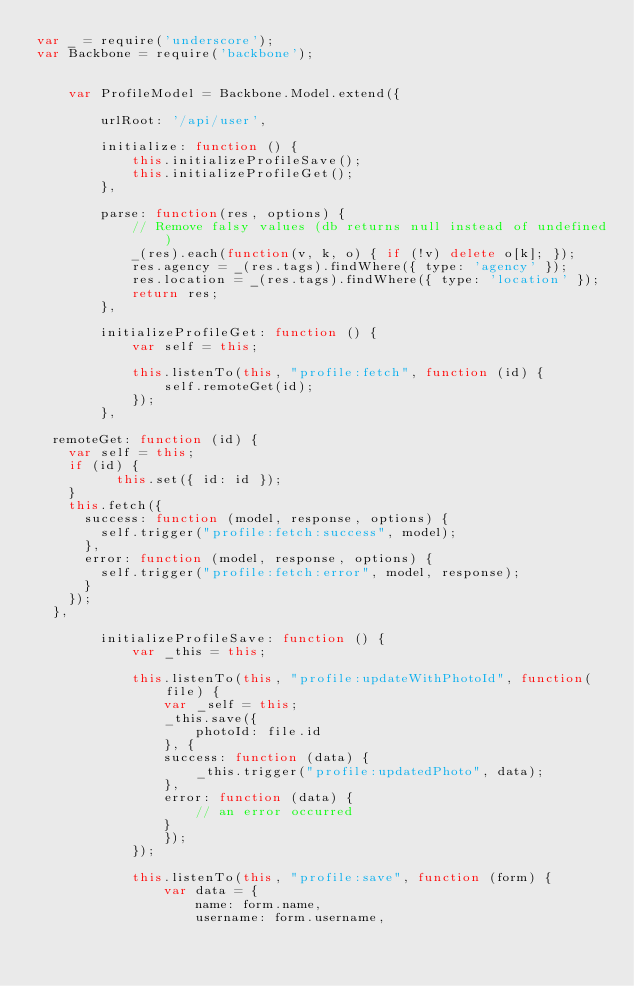<code> <loc_0><loc_0><loc_500><loc_500><_JavaScript_>var _ = require('underscore');
var Backbone = require('backbone');


	var ProfileModel = Backbone.Model.extend({

		urlRoot: '/api/user',

		initialize: function () {
			this.initializeProfileSave();
			this.initializeProfileGet();
		},

		parse: function(res, options) {
			// Remove falsy values (db returns null instead of undefined)
			_(res).each(function(v, k, o) { if (!v) delete o[k]; });
			res.agency = _(res.tags).findWhere({ type: 'agency' });
			res.location = _(res.tags).findWhere({ type: 'location' });
			return res;
		},

		initializeProfileGet: function () {
			var self = this;

			this.listenTo(this, "profile:fetch", function (id) {
				self.remoteGet(id);
			});
		},

  remoteGet: function (id) {
    var self = this;
    if (id) {
	      this.set({ id: id });
    }
    this.fetch({
      success: function (model, response, options) {
        self.trigger("profile:fetch:success", model);
      },
      error: function (model, response, options) {
        self.trigger("profile:fetch:error", model, response);
      }
    });
  },

		initializeProfileSave: function () {
			var _this = this;

			this.listenTo(this, "profile:updateWithPhotoId", function(file) {
				var _self = this;
				_this.save({
					photoId: file.id
				}, {
				success: function (data) {
					_this.trigger("profile:updatedPhoto", data);
				},
				error: function (data) {
					// an error occurred
				}
				});
			});

			this.listenTo(this, "profile:save", function (form) {
				var data = {
					name: form.name,
					username: form.username,</code> 